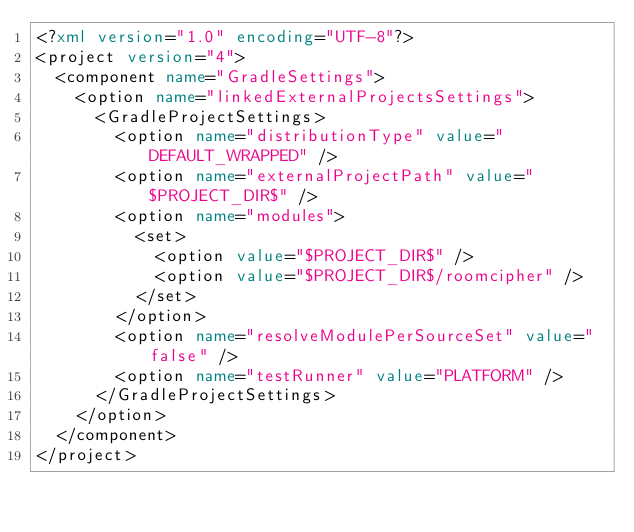Convert code to text. <code><loc_0><loc_0><loc_500><loc_500><_XML_><?xml version="1.0" encoding="UTF-8"?>
<project version="4">
  <component name="GradleSettings">
    <option name="linkedExternalProjectsSettings">
      <GradleProjectSettings>
        <option name="distributionType" value="DEFAULT_WRAPPED" />
        <option name="externalProjectPath" value="$PROJECT_DIR$" />
        <option name="modules">
          <set>
            <option value="$PROJECT_DIR$" />
            <option value="$PROJECT_DIR$/roomcipher" />
          </set>
        </option>
        <option name="resolveModulePerSourceSet" value="false" />
        <option name="testRunner" value="PLATFORM" />
      </GradleProjectSettings>
    </option>
  </component>
</project></code> 